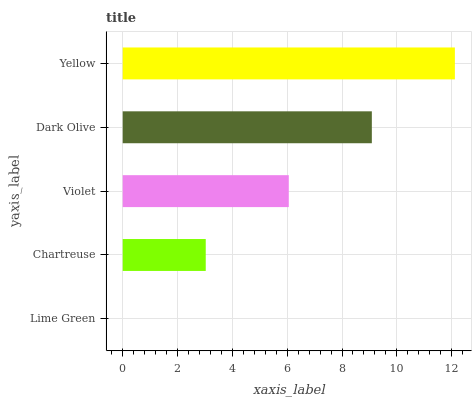Is Lime Green the minimum?
Answer yes or no. Yes. Is Yellow the maximum?
Answer yes or no. Yes. Is Chartreuse the minimum?
Answer yes or no. No. Is Chartreuse the maximum?
Answer yes or no. No. Is Chartreuse greater than Lime Green?
Answer yes or no. Yes. Is Lime Green less than Chartreuse?
Answer yes or no. Yes. Is Lime Green greater than Chartreuse?
Answer yes or no. No. Is Chartreuse less than Lime Green?
Answer yes or no. No. Is Violet the high median?
Answer yes or no. Yes. Is Violet the low median?
Answer yes or no. Yes. Is Chartreuse the high median?
Answer yes or no. No. Is Lime Green the low median?
Answer yes or no. No. 